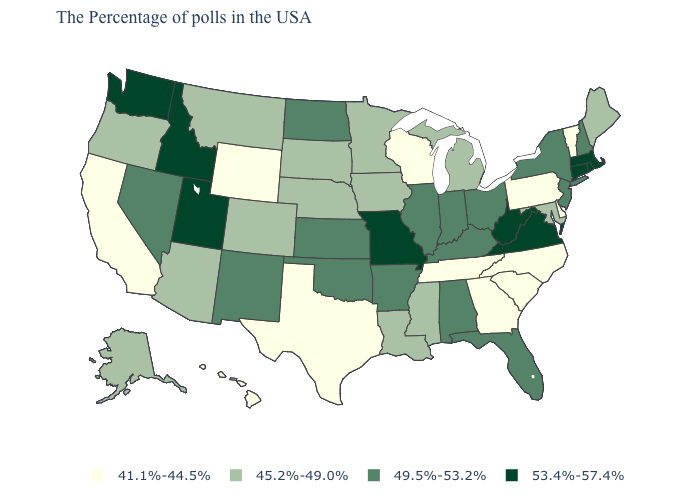Name the states that have a value in the range 53.4%-57.4%?
Quick response, please. Massachusetts, Rhode Island, Connecticut, Virginia, West Virginia, Missouri, Utah, Idaho, Washington. What is the value of Arizona?
Keep it brief. 45.2%-49.0%. What is the value of Illinois?
Quick response, please. 49.5%-53.2%. Among the states that border Pennsylvania , which have the lowest value?
Write a very short answer. Delaware. What is the value of Arizona?
Give a very brief answer. 45.2%-49.0%. Which states have the highest value in the USA?
Keep it brief. Massachusetts, Rhode Island, Connecticut, Virginia, West Virginia, Missouri, Utah, Idaho, Washington. Name the states that have a value in the range 53.4%-57.4%?
Write a very short answer. Massachusetts, Rhode Island, Connecticut, Virginia, West Virginia, Missouri, Utah, Idaho, Washington. Name the states that have a value in the range 53.4%-57.4%?
Quick response, please. Massachusetts, Rhode Island, Connecticut, Virginia, West Virginia, Missouri, Utah, Idaho, Washington. Does the map have missing data?
Write a very short answer. No. What is the highest value in the West ?
Quick response, please. 53.4%-57.4%. What is the lowest value in the MidWest?
Give a very brief answer. 41.1%-44.5%. What is the highest value in the West ?
Concise answer only. 53.4%-57.4%. What is the value of Georgia?
Give a very brief answer. 41.1%-44.5%. Is the legend a continuous bar?
Be succinct. No. What is the highest value in states that border California?
Answer briefly. 49.5%-53.2%. 